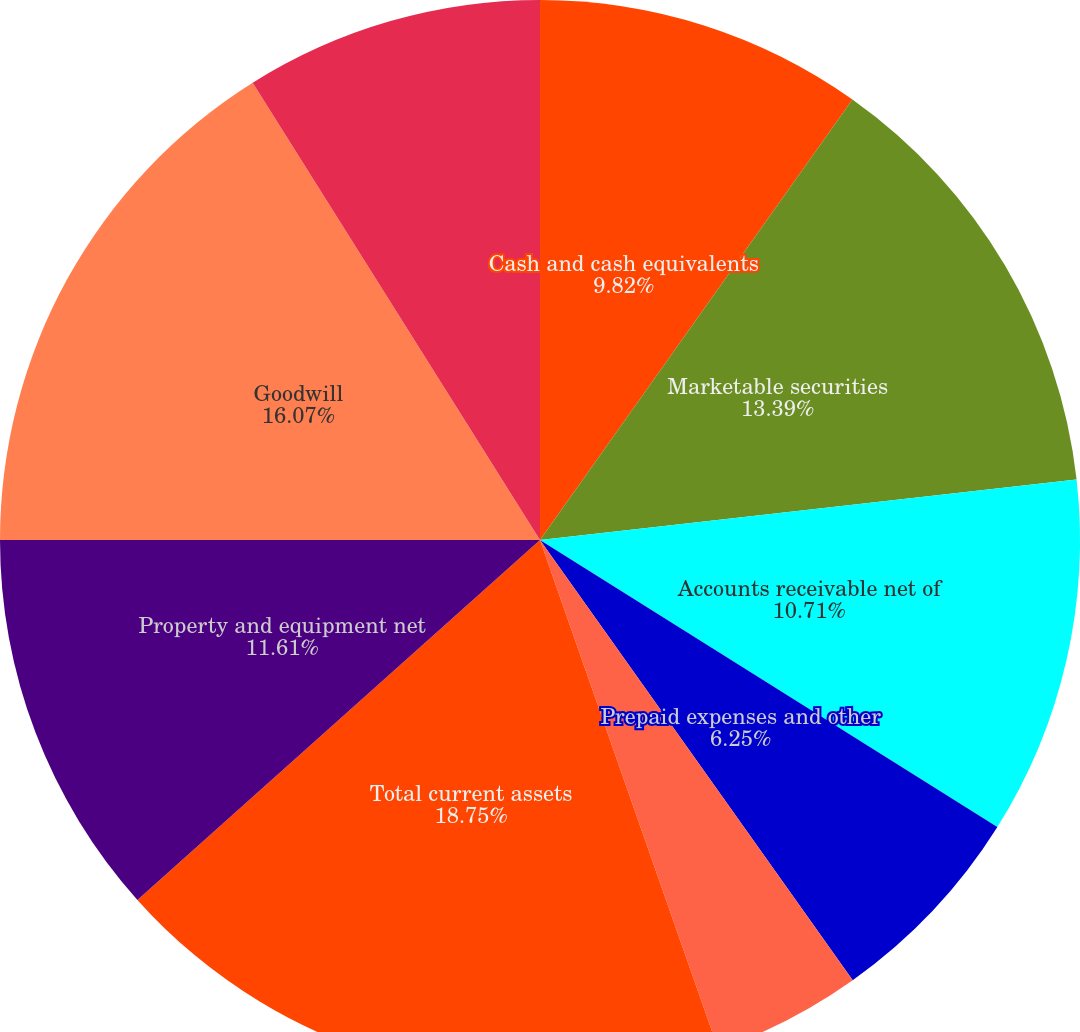<chart> <loc_0><loc_0><loc_500><loc_500><pie_chart><fcel>Cash and cash equivalents<fcel>Marketable securities<fcel>Accounts receivable net of<fcel>Prepaid expenses and other<fcel>Deferred income tax assets<fcel>Total current assets<fcel>Property and equipment net<fcel>Goodwill<fcel>Other intangible assets net<nl><fcel>9.82%<fcel>13.39%<fcel>10.71%<fcel>6.25%<fcel>4.47%<fcel>18.75%<fcel>11.61%<fcel>16.07%<fcel>8.93%<nl></chart> 